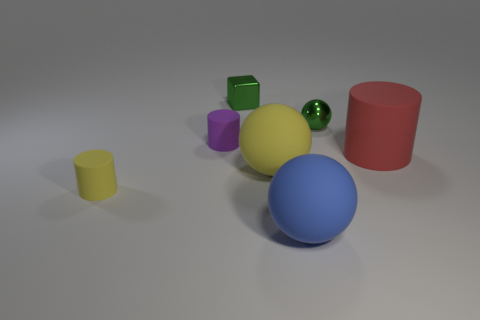Subtract all small green balls. How many balls are left? 2 Add 2 gray shiny cylinders. How many objects exist? 9 Subtract 0 yellow cubes. How many objects are left? 7 Subtract all spheres. How many objects are left? 4 Subtract 2 cylinders. How many cylinders are left? 1 Subtract all purple spheres. Subtract all red cylinders. How many spheres are left? 3 Subtract all purple balls. How many cyan cylinders are left? 0 Subtract all large blue matte balls. Subtract all tiny yellow objects. How many objects are left? 5 Add 6 purple rubber things. How many purple rubber things are left? 7 Add 2 tiny blue metallic cubes. How many tiny blue metallic cubes exist? 2 